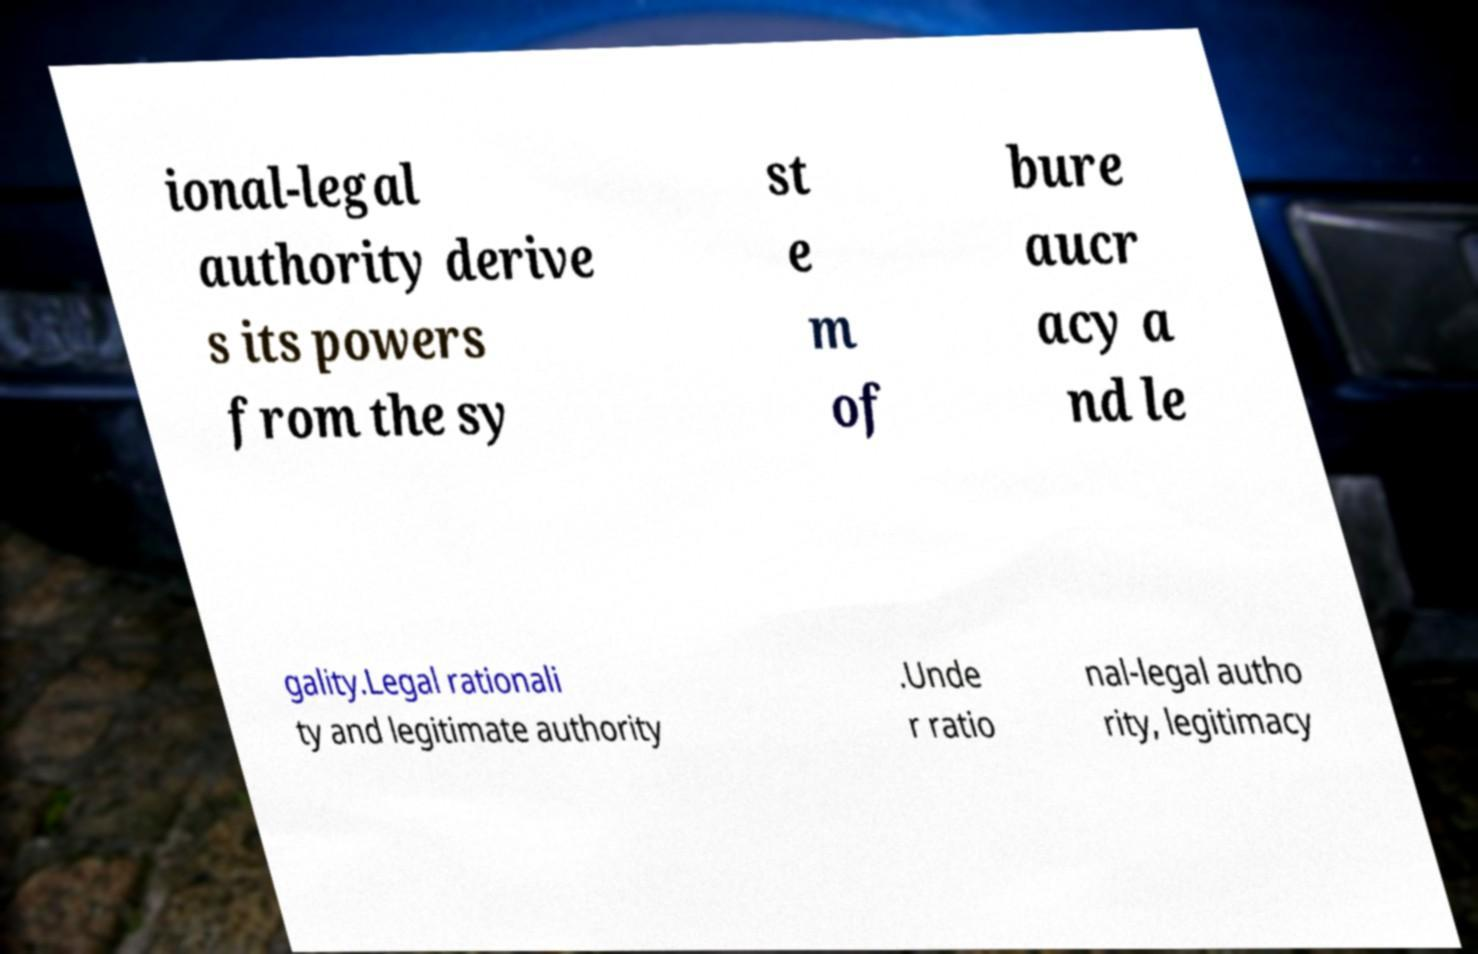Could you assist in decoding the text presented in this image and type it out clearly? ional-legal authority derive s its powers from the sy st e m of bure aucr acy a nd le gality.Legal rationali ty and legitimate authority .Unde r ratio nal-legal autho rity, legitimacy 